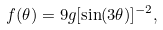<formula> <loc_0><loc_0><loc_500><loc_500>f ( \theta ) = 9 g [ \sin ( 3 \theta ) ] ^ { - 2 } ,</formula> 